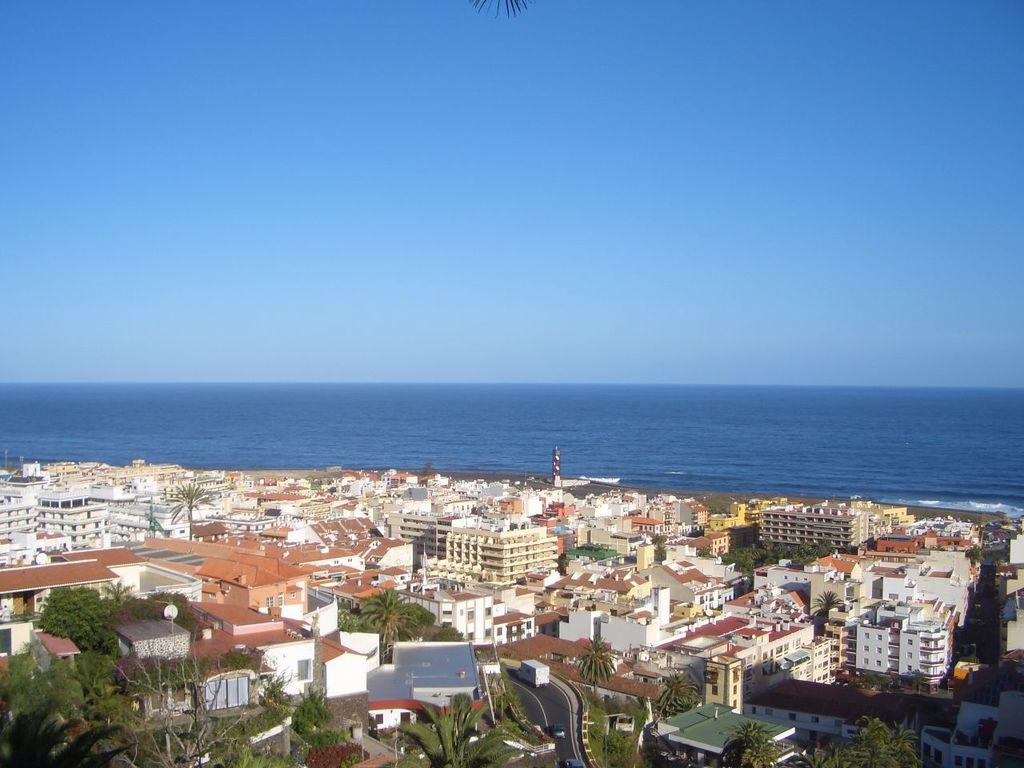In one or two sentences, can you explain what this image depicts? In this image, we can see some buildings, trees. We can see the ground and some vehicles. We can see some water and the sky. 